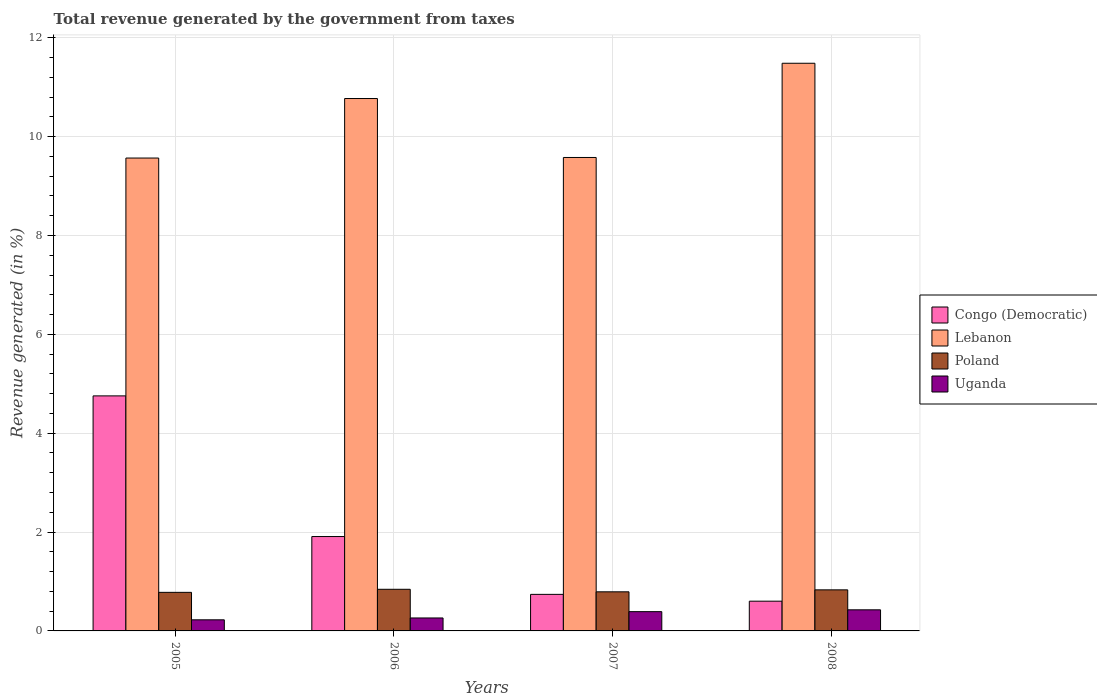What is the total revenue generated in Poland in 2007?
Ensure brevity in your answer.  0.79. Across all years, what is the maximum total revenue generated in Poland?
Offer a very short reply. 0.84. Across all years, what is the minimum total revenue generated in Congo (Democratic)?
Your answer should be very brief. 0.6. In which year was the total revenue generated in Lebanon maximum?
Keep it short and to the point. 2008. What is the total total revenue generated in Poland in the graph?
Make the answer very short. 3.24. What is the difference between the total revenue generated in Lebanon in 2005 and that in 2006?
Offer a terse response. -1.2. What is the difference between the total revenue generated in Poland in 2008 and the total revenue generated in Lebanon in 2007?
Your response must be concise. -8.75. What is the average total revenue generated in Congo (Democratic) per year?
Your answer should be very brief. 2. In the year 2007, what is the difference between the total revenue generated in Poland and total revenue generated in Uganda?
Your answer should be compact. 0.4. In how many years, is the total revenue generated in Uganda greater than 2.4 %?
Offer a terse response. 0. What is the ratio of the total revenue generated in Lebanon in 2006 to that in 2007?
Ensure brevity in your answer.  1.12. Is the total revenue generated in Congo (Democratic) in 2005 less than that in 2007?
Offer a very short reply. No. Is the difference between the total revenue generated in Poland in 2006 and 2007 greater than the difference between the total revenue generated in Uganda in 2006 and 2007?
Ensure brevity in your answer.  Yes. What is the difference between the highest and the second highest total revenue generated in Poland?
Offer a very short reply. 0.01. What is the difference between the highest and the lowest total revenue generated in Uganda?
Your answer should be very brief. 0.2. Is it the case that in every year, the sum of the total revenue generated in Poland and total revenue generated in Congo (Democratic) is greater than the sum of total revenue generated in Lebanon and total revenue generated in Uganda?
Keep it short and to the point. Yes. What does the 4th bar from the left in 2006 represents?
Ensure brevity in your answer.  Uganda. What does the 1st bar from the right in 2005 represents?
Make the answer very short. Uganda. How many bars are there?
Offer a very short reply. 16. Are all the bars in the graph horizontal?
Offer a terse response. No. Does the graph contain grids?
Your answer should be very brief. Yes. How are the legend labels stacked?
Your response must be concise. Vertical. What is the title of the graph?
Give a very brief answer. Total revenue generated by the government from taxes. What is the label or title of the X-axis?
Keep it short and to the point. Years. What is the label or title of the Y-axis?
Ensure brevity in your answer.  Revenue generated (in %). What is the Revenue generated (in %) of Congo (Democratic) in 2005?
Give a very brief answer. 4.75. What is the Revenue generated (in %) in Lebanon in 2005?
Make the answer very short. 9.57. What is the Revenue generated (in %) in Poland in 2005?
Provide a succinct answer. 0.78. What is the Revenue generated (in %) in Uganda in 2005?
Make the answer very short. 0.22. What is the Revenue generated (in %) in Congo (Democratic) in 2006?
Keep it short and to the point. 1.91. What is the Revenue generated (in %) in Lebanon in 2006?
Ensure brevity in your answer.  10.77. What is the Revenue generated (in %) of Poland in 2006?
Your answer should be compact. 0.84. What is the Revenue generated (in %) in Uganda in 2006?
Your answer should be very brief. 0.26. What is the Revenue generated (in %) in Congo (Democratic) in 2007?
Your answer should be very brief. 0.74. What is the Revenue generated (in %) of Lebanon in 2007?
Offer a very short reply. 9.58. What is the Revenue generated (in %) in Poland in 2007?
Your answer should be very brief. 0.79. What is the Revenue generated (in %) of Uganda in 2007?
Ensure brevity in your answer.  0.39. What is the Revenue generated (in %) of Congo (Democratic) in 2008?
Give a very brief answer. 0.6. What is the Revenue generated (in %) in Lebanon in 2008?
Your answer should be compact. 11.48. What is the Revenue generated (in %) of Poland in 2008?
Give a very brief answer. 0.83. What is the Revenue generated (in %) of Uganda in 2008?
Provide a short and direct response. 0.43. Across all years, what is the maximum Revenue generated (in %) in Congo (Democratic)?
Keep it short and to the point. 4.75. Across all years, what is the maximum Revenue generated (in %) of Lebanon?
Provide a short and direct response. 11.48. Across all years, what is the maximum Revenue generated (in %) of Poland?
Your answer should be very brief. 0.84. Across all years, what is the maximum Revenue generated (in %) of Uganda?
Provide a short and direct response. 0.43. Across all years, what is the minimum Revenue generated (in %) of Congo (Democratic)?
Provide a short and direct response. 0.6. Across all years, what is the minimum Revenue generated (in %) of Lebanon?
Make the answer very short. 9.57. Across all years, what is the minimum Revenue generated (in %) in Poland?
Make the answer very short. 0.78. Across all years, what is the minimum Revenue generated (in %) of Uganda?
Your answer should be compact. 0.22. What is the total Revenue generated (in %) in Congo (Democratic) in the graph?
Provide a short and direct response. 8.01. What is the total Revenue generated (in %) in Lebanon in the graph?
Provide a succinct answer. 41.4. What is the total Revenue generated (in %) of Poland in the graph?
Your answer should be very brief. 3.24. What is the total Revenue generated (in %) of Uganda in the graph?
Keep it short and to the point. 1.3. What is the difference between the Revenue generated (in %) in Congo (Democratic) in 2005 and that in 2006?
Offer a terse response. 2.85. What is the difference between the Revenue generated (in %) of Lebanon in 2005 and that in 2006?
Ensure brevity in your answer.  -1.2. What is the difference between the Revenue generated (in %) in Poland in 2005 and that in 2006?
Offer a very short reply. -0.06. What is the difference between the Revenue generated (in %) of Uganda in 2005 and that in 2006?
Ensure brevity in your answer.  -0.04. What is the difference between the Revenue generated (in %) in Congo (Democratic) in 2005 and that in 2007?
Offer a terse response. 4.02. What is the difference between the Revenue generated (in %) of Lebanon in 2005 and that in 2007?
Keep it short and to the point. -0.01. What is the difference between the Revenue generated (in %) in Poland in 2005 and that in 2007?
Ensure brevity in your answer.  -0.01. What is the difference between the Revenue generated (in %) in Uganda in 2005 and that in 2007?
Ensure brevity in your answer.  -0.17. What is the difference between the Revenue generated (in %) of Congo (Democratic) in 2005 and that in 2008?
Your answer should be very brief. 4.15. What is the difference between the Revenue generated (in %) of Lebanon in 2005 and that in 2008?
Provide a succinct answer. -1.92. What is the difference between the Revenue generated (in %) in Poland in 2005 and that in 2008?
Keep it short and to the point. -0.05. What is the difference between the Revenue generated (in %) in Uganda in 2005 and that in 2008?
Offer a terse response. -0.2. What is the difference between the Revenue generated (in %) in Congo (Democratic) in 2006 and that in 2007?
Provide a short and direct response. 1.17. What is the difference between the Revenue generated (in %) of Lebanon in 2006 and that in 2007?
Provide a short and direct response. 1.19. What is the difference between the Revenue generated (in %) of Poland in 2006 and that in 2007?
Offer a terse response. 0.05. What is the difference between the Revenue generated (in %) of Uganda in 2006 and that in 2007?
Your response must be concise. -0.13. What is the difference between the Revenue generated (in %) in Congo (Democratic) in 2006 and that in 2008?
Your answer should be very brief. 1.31. What is the difference between the Revenue generated (in %) in Lebanon in 2006 and that in 2008?
Offer a very short reply. -0.71. What is the difference between the Revenue generated (in %) in Poland in 2006 and that in 2008?
Offer a very short reply. 0.01. What is the difference between the Revenue generated (in %) in Uganda in 2006 and that in 2008?
Make the answer very short. -0.16. What is the difference between the Revenue generated (in %) in Congo (Democratic) in 2007 and that in 2008?
Your answer should be very brief. 0.14. What is the difference between the Revenue generated (in %) of Lebanon in 2007 and that in 2008?
Keep it short and to the point. -1.91. What is the difference between the Revenue generated (in %) in Poland in 2007 and that in 2008?
Your answer should be compact. -0.04. What is the difference between the Revenue generated (in %) of Uganda in 2007 and that in 2008?
Your answer should be very brief. -0.04. What is the difference between the Revenue generated (in %) in Congo (Democratic) in 2005 and the Revenue generated (in %) in Lebanon in 2006?
Offer a very short reply. -6.02. What is the difference between the Revenue generated (in %) of Congo (Democratic) in 2005 and the Revenue generated (in %) of Poland in 2006?
Your response must be concise. 3.91. What is the difference between the Revenue generated (in %) in Congo (Democratic) in 2005 and the Revenue generated (in %) in Uganda in 2006?
Offer a terse response. 4.49. What is the difference between the Revenue generated (in %) in Lebanon in 2005 and the Revenue generated (in %) in Poland in 2006?
Ensure brevity in your answer.  8.72. What is the difference between the Revenue generated (in %) of Lebanon in 2005 and the Revenue generated (in %) of Uganda in 2006?
Make the answer very short. 9.3. What is the difference between the Revenue generated (in %) in Poland in 2005 and the Revenue generated (in %) in Uganda in 2006?
Keep it short and to the point. 0.52. What is the difference between the Revenue generated (in %) of Congo (Democratic) in 2005 and the Revenue generated (in %) of Lebanon in 2007?
Give a very brief answer. -4.82. What is the difference between the Revenue generated (in %) in Congo (Democratic) in 2005 and the Revenue generated (in %) in Poland in 2007?
Provide a short and direct response. 3.96. What is the difference between the Revenue generated (in %) of Congo (Democratic) in 2005 and the Revenue generated (in %) of Uganda in 2007?
Offer a terse response. 4.36. What is the difference between the Revenue generated (in %) in Lebanon in 2005 and the Revenue generated (in %) in Poland in 2007?
Keep it short and to the point. 8.78. What is the difference between the Revenue generated (in %) of Lebanon in 2005 and the Revenue generated (in %) of Uganda in 2007?
Give a very brief answer. 9.18. What is the difference between the Revenue generated (in %) of Poland in 2005 and the Revenue generated (in %) of Uganda in 2007?
Provide a succinct answer. 0.39. What is the difference between the Revenue generated (in %) of Congo (Democratic) in 2005 and the Revenue generated (in %) of Lebanon in 2008?
Your answer should be very brief. -6.73. What is the difference between the Revenue generated (in %) of Congo (Democratic) in 2005 and the Revenue generated (in %) of Poland in 2008?
Make the answer very short. 3.92. What is the difference between the Revenue generated (in %) of Congo (Democratic) in 2005 and the Revenue generated (in %) of Uganda in 2008?
Offer a terse response. 4.33. What is the difference between the Revenue generated (in %) in Lebanon in 2005 and the Revenue generated (in %) in Poland in 2008?
Your response must be concise. 8.74. What is the difference between the Revenue generated (in %) of Lebanon in 2005 and the Revenue generated (in %) of Uganda in 2008?
Keep it short and to the point. 9.14. What is the difference between the Revenue generated (in %) in Poland in 2005 and the Revenue generated (in %) in Uganda in 2008?
Provide a short and direct response. 0.35. What is the difference between the Revenue generated (in %) in Congo (Democratic) in 2006 and the Revenue generated (in %) in Lebanon in 2007?
Provide a short and direct response. -7.67. What is the difference between the Revenue generated (in %) of Congo (Democratic) in 2006 and the Revenue generated (in %) of Poland in 2007?
Your answer should be very brief. 1.12. What is the difference between the Revenue generated (in %) of Congo (Democratic) in 2006 and the Revenue generated (in %) of Uganda in 2007?
Your response must be concise. 1.52. What is the difference between the Revenue generated (in %) in Lebanon in 2006 and the Revenue generated (in %) in Poland in 2007?
Keep it short and to the point. 9.98. What is the difference between the Revenue generated (in %) in Lebanon in 2006 and the Revenue generated (in %) in Uganda in 2007?
Your response must be concise. 10.38. What is the difference between the Revenue generated (in %) of Poland in 2006 and the Revenue generated (in %) of Uganda in 2007?
Provide a short and direct response. 0.45. What is the difference between the Revenue generated (in %) in Congo (Democratic) in 2006 and the Revenue generated (in %) in Lebanon in 2008?
Your answer should be very brief. -9.57. What is the difference between the Revenue generated (in %) in Congo (Democratic) in 2006 and the Revenue generated (in %) in Poland in 2008?
Your answer should be compact. 1.08. What is the difference between the Revenue generated (in %) in Congo (Democratic) in 2006 and the Revenue generated (in %) in Uganda in 2008?
Give a very brief answer. 1.48. What is the difference between the Revenue generated (in %) in Lebanon in 2006 and the Revenue generated (in %) in Poland in 2008?
Your answer should be very brief. 9.94. What is the difference between the Revenue generated (in %) of Lebanon in 2006 and the Revenue generated (in %) of Uganda in 2008?
Your answer should be compact. 10.34. What is the difference between the Revenue generated (in %) in Poland in 2006 and the Revenue generated (in %) in Uganda in 2008?
Offer a very short reply. 0.42. What is the difference between the Revenue generated (in %) in Congo (Democratic) in 2007 and the Revenue generated (in %) in Lebanon in 2008?
Your response must be concise. -10.74. What is the difference between the Revenue generated (in %) of Congo (Democratic) in 2007 and the Revenue generated (in %) of Poland in 2008?
Give a very brief answer. -0.09. What is the difference between the Revenue generated (in %) in Congo (Democratic) in 2007 and the Revenue generated (in %) in Uganda in 2008?
Your answer should be compact. 0.31. What is the difference between the Revenue generated (in %) of Lebanon in 2007 and the Revenue generated (in %) of Poland in 2008?
Offer a terse response. 8.75. What is the difference between the Revenue generated (in %) in Lebanon in 2007 and the Revenue generated (in %) in Uganda in 2008?
Offer a terse response. 9.15. What is the difference between the Revenue generated (in %) of Poland in 2007 and the Revenue generated (in %) of Uganda in 2008?
Provide a short and direct response. 0.36. What is the average Revenue generated (in %) in Congo (Democratic) per year?
Your answer should be compact. 2. What is the average Revenue generated (in %) in Lebanon per year?
Give a very brief answer. 10.35. What is the average Revenue generated (in %) in Poland per year?
Your response must be concise. 0.81. What is the average Revenue generated (in %) in Uganda per year?
Keep it short and to the point. 0.33. In the year 2005, what is the difference between the Revenue generated (in %) in Congo (Democratic) and Revenue generated (in %) in Lebanon?
Give a very brief answer. -4.81. In the year 2005, what is the difference between the Revenue generated (in %) in Congo (Democratic) and Revenue generated (in %) in Poland?
Ensure brevity in your answer.  3.97. In the year 2005, what is the difference between the Revenue generated (in %) of Congo (Democratic) and Revenue generated (in %) of Uganda?
Offer a very short reply. 4.53. In the year 2005, what is the difference between the Revenue generated (in %) in Lebanon and Revenue generated (in %) in Poland?
Ensure brevity in your answer.  8.79. In the year 2005, what is the difference between the Revenue generated (in %) of Lebanon and Revenue generated (in %) of Uganda?
Your response must be concise. 9.34. In the year 2005, what is the difference between the Revenue generated (in %) in Poland and Revenue generated (in %) in Uganda?
Your answer should be very brief. 0.56. In the year 2006, what is the difference between the Revenue generated (in %) of Congo (Democratic) and Revenue generated (in %) of Lebanon?
Offer a very short reply. -8.86. In the year 2006, what is the difference between the Revenue generated (in %) of Congo (Democratic) and Revenue generated (in %) of Poland?
Make the answer very short. 1.07. In the year 2006, what is the difference between the Revenue generated (in %) in Congo (Democratic) and Revenue generated (in %) in Uganda?
Your response must be concise. 1.65. In the year 2006, what is the difference between the Revenue generated (in %) of Lebanon and Revenue generated (in %) of Poland?
Make the answer very short. 9.93. In the year 2006, what is the difference between the Revenue generated (in %) in Lebanon and Revenue generated (in %) in Uganda?
Provide a short and direct response. 10.51. In the year 2006, what is the difference between the Revenue generated (in %) in Poland and Revenue generated (in %) in Uganda?
Give a very brief answer. 0.58. In the year 2007, what is the difference between the Revenue generated (in %) of Congo (Democratic) and Revenue generated (in %) of Lebanon?
Give a very brief answer. -8.84. In the year 2007, what is the difference between the Revenue generated (in %) of Congo (Democratic) and Revenue generated (in %) of Poland?
Give a very brief answer. -0.05. In the year 2007, what is the difference between the Revenue generated (in %) in Congo (Democratic) and Revenue generated (in %) in Uganda?
Your answer should be compact. 0.35. In the year 2007, what is the difference between the Revenue generated (in %) of Lebanon and Revenue generated (in %) of Poland?
Keep it short and to the point. 8.79. In the year 2007, what is the difference between the Revenue generated (in %) of Lebanon and Revenue generated (in %) of Uganda?
Offer a very short reply. 9.19. In the year 2007, what is the difference between the Revenue generated (in %) of Poland and Revenue generated (in %) of Uganda?
Provide a succinct answer. 0.4. In the year 2008, what is the difference between the Revenue generated (in %) in Congo (Democratic) and Revenue generated (in %) in Lebanon?
Offer a terse response. -10.88. In the year 2008, what is the difference between the Revenue generated (in %) of Congo (Democratic) and Revenue generated (in %) of Poland?
Provide a succinct answer. -0.23. In the year 2008, what is the difference between the Revenue generated (in %) in Congo (Democratic) and Revenue generated (in %) in Uganda?
Offer a terse response. 0.17. In the year 2008, what is the difference between the Revenue generated (in %) in Lebanon and Revenue generated (in %) in Poland?
Give a very brief answer. 10.65. In the year 2008, what is the difference between the Revenue generated (in %) of Lebanon and Revenue generated (in %) of Uganda?
Keep it short and to the point. 11.06. In the year 2008, what is the difference between the Revenue generated (in %) of Poland and Revenue generated (in %) of Uganda?
Ensure brevity in your answer.  0.4. What is the ratio of the Revenue generated (in %) of Congo (Democratic) in 2005 to that in 2006?
Make the answer very short. 2.49. What is the ratio of the Revenue generated (in %) in Lebanon in 2005 to that in 2006?
Your response must be concise. 0.89. What is the ratio of the Revenue generated (in %) of Poland in 2005 to that in 2006?
Provide a short and direct response. 0.93. What is the ratio of the Revenue generated (in %) in Uganda in 2005 to that in 2006?
Offer a very short reply. 0.86. What is the ratio of the Revenue generated (in %) in Congo (Democratic) in 2005 to that in 2007?
Your response must be concise. 6.43. What is the ratio of the Revenue generated (in %) in Poland in 2005 to that in 2007?
Ensure brevity in your answer.  0.99. What is the ratio of the Revenue generated (in %) in Uganda in 2005 to that in 2007?
Keep it short and to the point. 0.58. What is the ratio of the Revenue generated (in %) of Congo (Democratic) in 2005 to that in 2008?
Give a very brief answer. 7.9. What is the ratio of the Revenue generated (in %) of Lebanon in 2005 to that in 2008?
Offer a very short reply. 0.83. What is the ratio of the Revenue generated (in %) in Poland in 2005 to that in 2008?
Offer a terse response. 0.94. What is the ratio of the Revenue generated (in %) in Uganda in 2005 to that in 2008?
Make the answer very short. 0.53. What is the ratio of the Revenue generated (in %) in Congo (Democratic) in 2006 to that in 2007?
Ensure brevity in your answer.  2.58. What is the ratio of the Revenue generated (in %) in Lebanon in 2006 to that in 2007?
Offer a terse response. 1.12. What is the ratio of the Revenue generated (in %) in Poland in 2006 to that in 2007?
Offer a very short reply. 1.06. What is the ratio of the Revenue generated (in %) in Uganda in 2006 to that in 2007?
Your answer should be very brief. 0.67. What is the ratio of the Revenue generated (in %) of Congo (Democratic) in 2006 to that in 2008?
Provide a short and direct response. 3.17. What is the ratio of the Revenue generated (in %) in Lebanon in 2006 to that in 2008?
Provide a succinct answer. 0.94. What is the ratio of the Revenue generated (in %) in Poland in 2006 to that in 2008?
Offer a terse response. 1.01. What is the ratio of the Revenue generated (in %) of Uganda in 2006 to that in 2008?
Your answer should be compact. 0.61. What is the ratio of the Revenue generated (in %) in Congo (Democratic) in 2007 to that in 2008?
Ensure brevity in your answer.  1.23. What is the ratio of the Revenue generated (in %) in Lebanon in 2007 to that in 2008?
Your answer should be compact. 0.83. What is the ratio of the Revenue generated (in %) of Poland in 2007 to that in 2008?
Your response must be concise. 0.95. What is the ratio of the Revenue generated (in %) of Uganda in 2007 to that in 2008?
Your answer should be very brief. 0.91. What is the difference between the highest and the second highest Revenue generated (in %) of Congo (Democratic)?
Keep it short and to the point. 2.85. What is the difference between the highest and the second highest Revenue generated (in %) in Lebanon?
Your response must be concise. 0.71. What is the difference between the highest and the second highest Revenue generated (in %) in Poland?
Ensure brevity in your answer.  0.01. What is the difference between the highest and the second highest Revenue generated (in %) of Uganda?
Your response must be concise. 0.04. What is the difference between the highest and the lowest Revenue generated (in %) in Congo (Democratic)?
Make the answer very short. 4.15. What is the difference between the highest and the lowest Revenue generated (in %) of Lebanon?
Your answer should be very brief. 1.92. What is the difference between the highest and the lowest Revenue generated (in %) in Poland?
Your answer should be very brief. 0.06. What is the difference between the highest and the lowest Revenue generated (in %) of Uganda?
Make the answer very short. 0.2. 